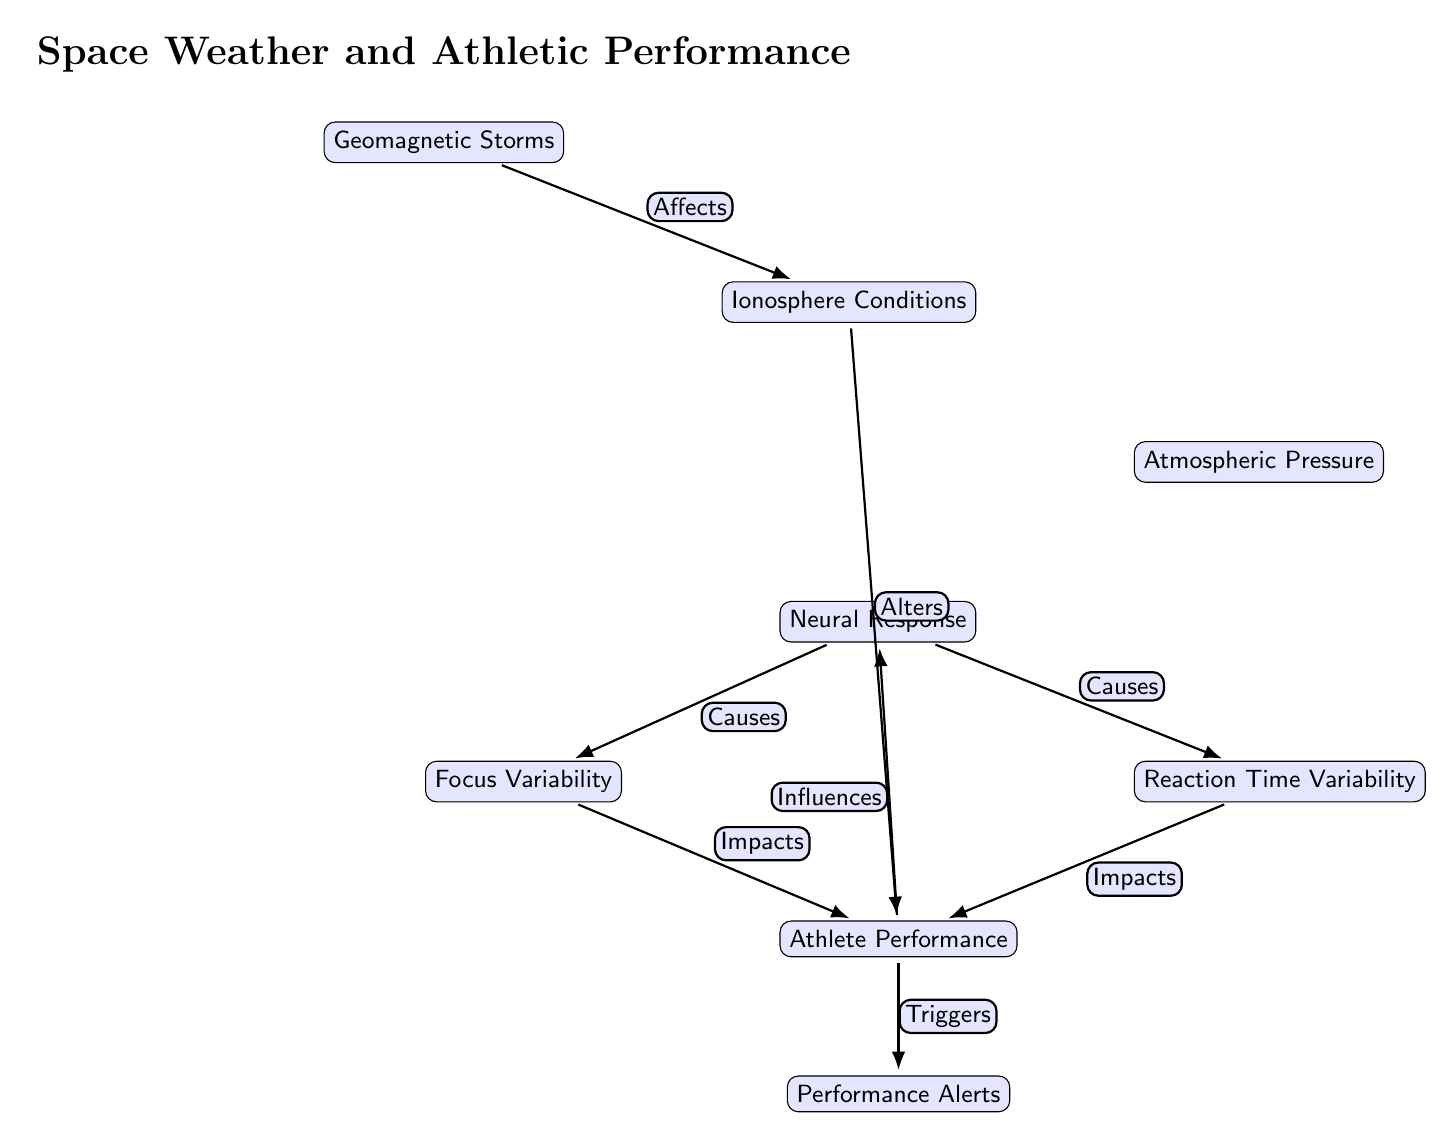What are the main components in the diagram? The diagram consists of the following nodes: Geomagnetic Storms, Ionosphere Conditions, Atmospheric Pressure, Neural Response, Focus Variability, Reaction Time Variability, Athlete Performance, and Performance Alerts.
Answer: Geomagnetic Storms, Ionosphere Conditions, Atmospheric Pressure, Neural Response, Focus Variability, Reaction Time Variability, Athlete Performance, Performance Alerts How many nodes are in the diagram? Counting each unique node listed in the diagram reveals there are a total of eight nodes: one for Geomagnetic Storms, one for Ionosphere Conditions, one for Atmospheric Pressure, one for Neural Response, one for Focus Variability, one for Reaction Time Variability, one for Athlete Performance, and one for Performance Alerts.
Answer: 8 Which node is affected by Geomagnetic Storms? The diagram shows that Geomagnetic Storms affect Ionosphere Conditions, which is directly connected to it.
Answer: Ionosphere Conditions What causes Focus Variability? The diagram indicates that the Neural Response causes Focus Variability, as it is directly connected to that node with an edge labeled "Causes."
Answer: Neural Response What triggers Performance Alerts? According to the diagram, Performance Alerts are triggered by Athlete Performance, which is influenced by both Focus Variability and Reaction Time Variability.
Answer: Athlete Performance Which factors influence Athlete Performance? The diagram shows that Athlete Performance is influenced by two variables: Focus Variability and Reaction Time Variability. Both of these are caused by Neural Response, which is influenced by Atmospheric Pressure.
Answer: Focus Variability, Reaction Time Variability Which two nodes have a direct influence connection to Atmospheric Pressure? The diagram shows that Atmospheric Pressure is influenced by Ionosphere Conditions, which in turn is affected by Geomagnetic Storms.
Answer: Ionosphere Conditions, Geomagnetic Storms How do Geomagnetic Storms affect athlete performance indirectly? The influence starts with Geomagnetic Storms affecting Ionosphere Conditions. This change alters Atmospheric Pressure, which then influences Neural Response, leading to Focus and Reaction Time Variability, ultimately impacting Athlete Performance.
Answer: Indirectly through Atmospheric Pressure and Neural Response 